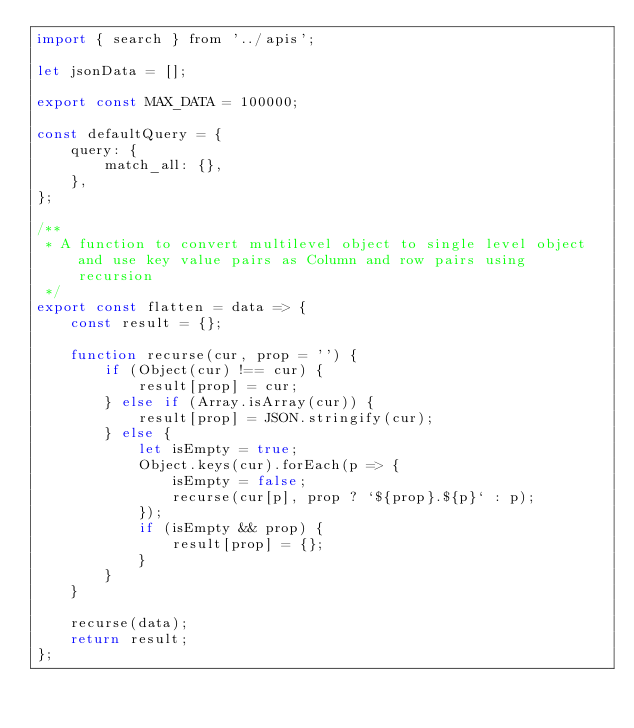Convert code to text. <code><loc_0><loc_0><loc_500><loc_500><_JavaScript_>import { search } from '../apis';

let jsonData = [];

export const MAX_DATA = 100000;

const defaultQuery = {
	query: {
		match_all: {},
	},
};

/**
 * A function to convert multilevel object to single level object and use key value pairs as Column and row pairs using recursion
 */
export const flatten = data => {
	const result = {};

	function recurse(cur, prop = '') {
		if (Object(cur) !== cur) {
			result[prop] = cur;
		} else if (Array.isArray(cur)) {
			result[prop] = JSON.stringify(cur);
		} else {
			let isEmpty = true;
			Object.keys(cur).forEach(p => {
				isEmpty = false;
				recurse(cur[p], prop ? `${prop}.${p}` : p);
			});
			if (isEmpty && prop) {
				result[prop] = {};
			}
		}
	}

	recurse(data);
	return result;
};
</code> 